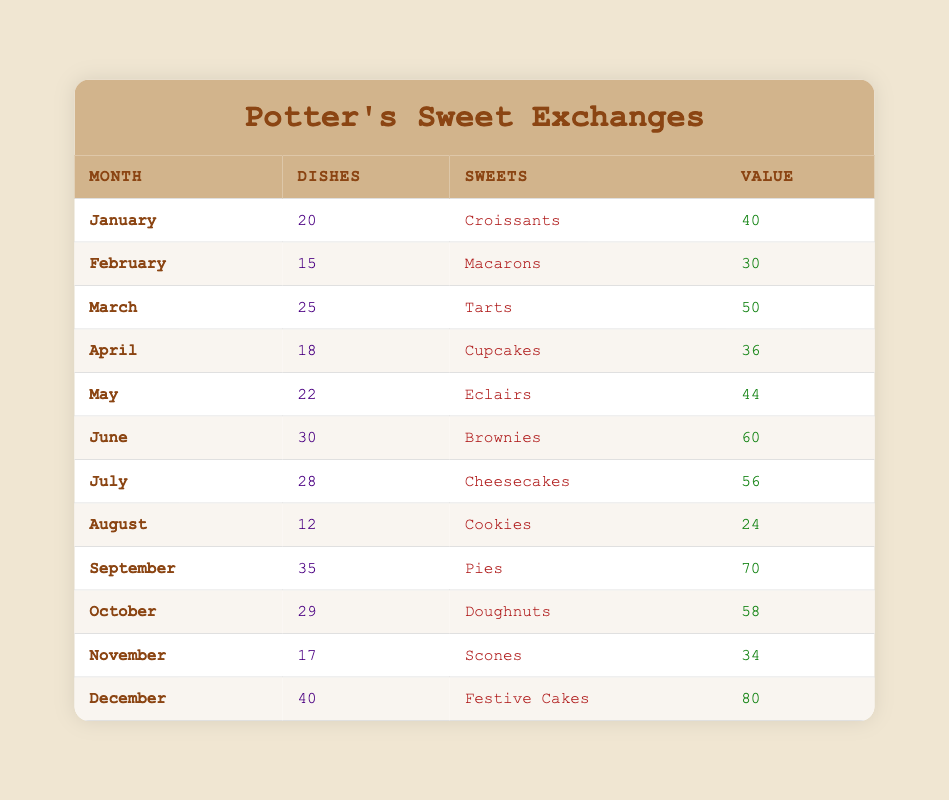What was the highest quantity of dishes traded in a month? The highest quantity of dishes is 40, which occurred in December.
Answer: 40 In which month were the least number of dishes traded? The least number of dishes are 12, which were traded in August.
Answer: August What is the total value of trades for the first quarter (January to March)? Adding the values for January (40), February (30), and March (50) gives a total of 40 + 30 + 50 = 120.
Answer: 120 Which sweet was exchanged in April? The sweet exchanged in April was Cupcakes.
Answer: Cupcakes What was the average quantity of dishes traded from May to July? The quantities for May (22), June (30), and July (28) sum up to 22 + 30 + 28 = 80, and the average is 80/3 = 26.67.
Answer: 26.67 Did the value of trade increase in December compared to November? Yes, in December the value was 80, which is higher than November's value of 34.
Answer: Yes Which month had the highest value of trade? The highest value of trade is 80 in December.
Answer: December How many more dishes were traded in June than in January? June had 30 dishes and January had 20 dishes, so 30 - 20 = 10 more dishes were traded in June.
Answer: 10 What is the total quantity of dishes traded from August to October? The quantities are August (12), September (35), and October (29), giving a total of 12 + 35 + 29 = 76.
Answer: 76 Which type of sweets did I trade for the most dishes? Pies were traded for the most dishes, a total of 35 in September.
Answer: Pies Was the value of trade ever equal to 34? Yes, the value of trade was equal to 34 in November.
Answer: Yes 